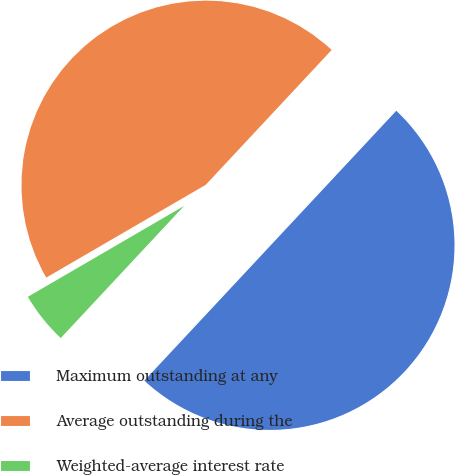<chart> <loc_0><loc_0><loc_500><loc_500><pie_chart><fcel>Maximum outstanding at any<fcel>Average outstanding during the<fcel>Weighted-average interest rate<nl><fcel>50.0%<fcel>45.34%<fcel>4.66%<nl></chart> 